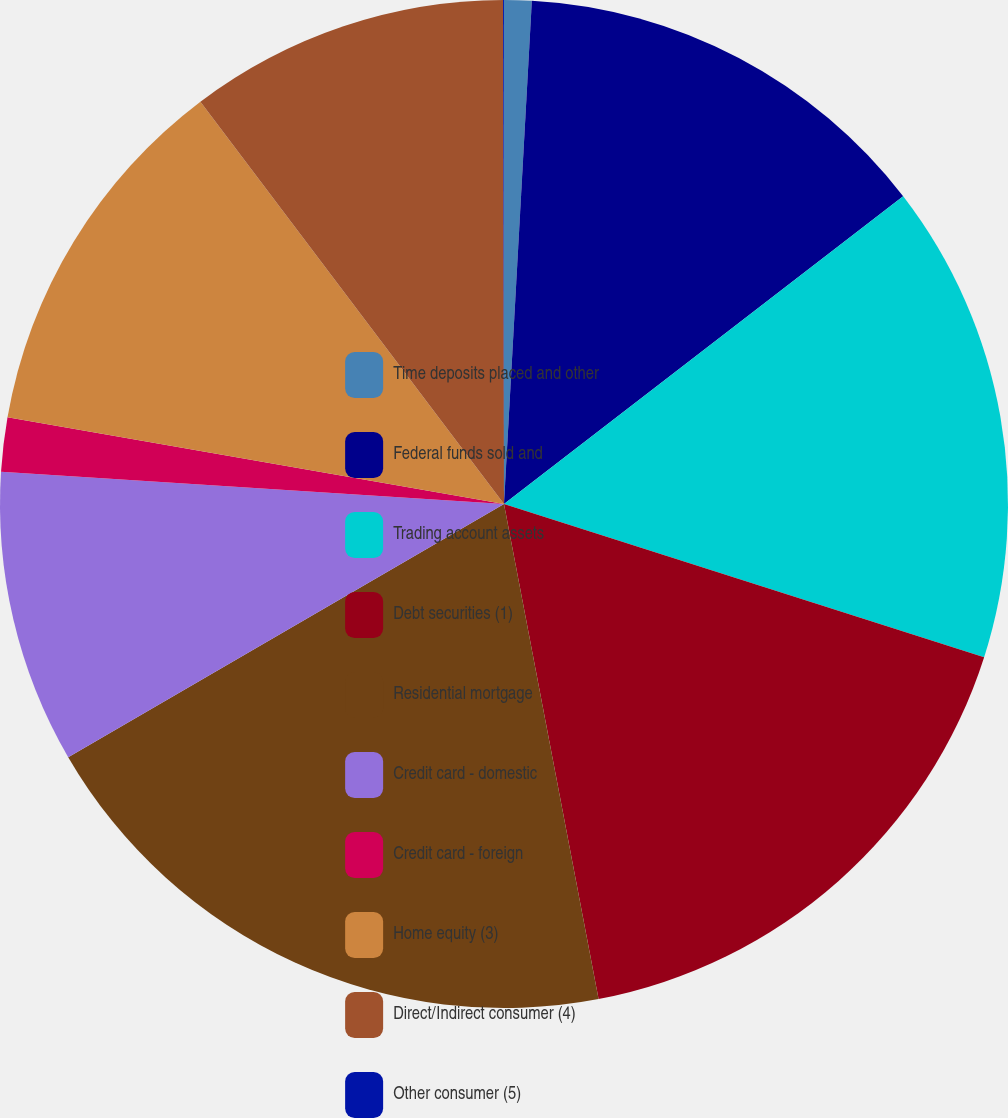Convert chart. <chart><loc_0><loc_0><loc_500><loc_500><pie_chart><fcel>Time deposits placed and other<fcel>Federal funds sold and<fcel>Trading account assets<fcel>Debt securities (1)<fcel>Residential mortgage<fcel>Credit card - domestic<fcel>Credit card - foreign<fcel>Home equity (3)<fcel>Direct/Indirect consumer (4)<fcel>Other consumer (5)<nl><fcel>0.88%<fcel>13.67%<fcel>15.37%<fcel>17.08%<fcel>19.63%<fcel>9.4%<fcel>1.73%<fcel>11.96%<fcel>10.26%<fcel>0.03%<nl></chart> 